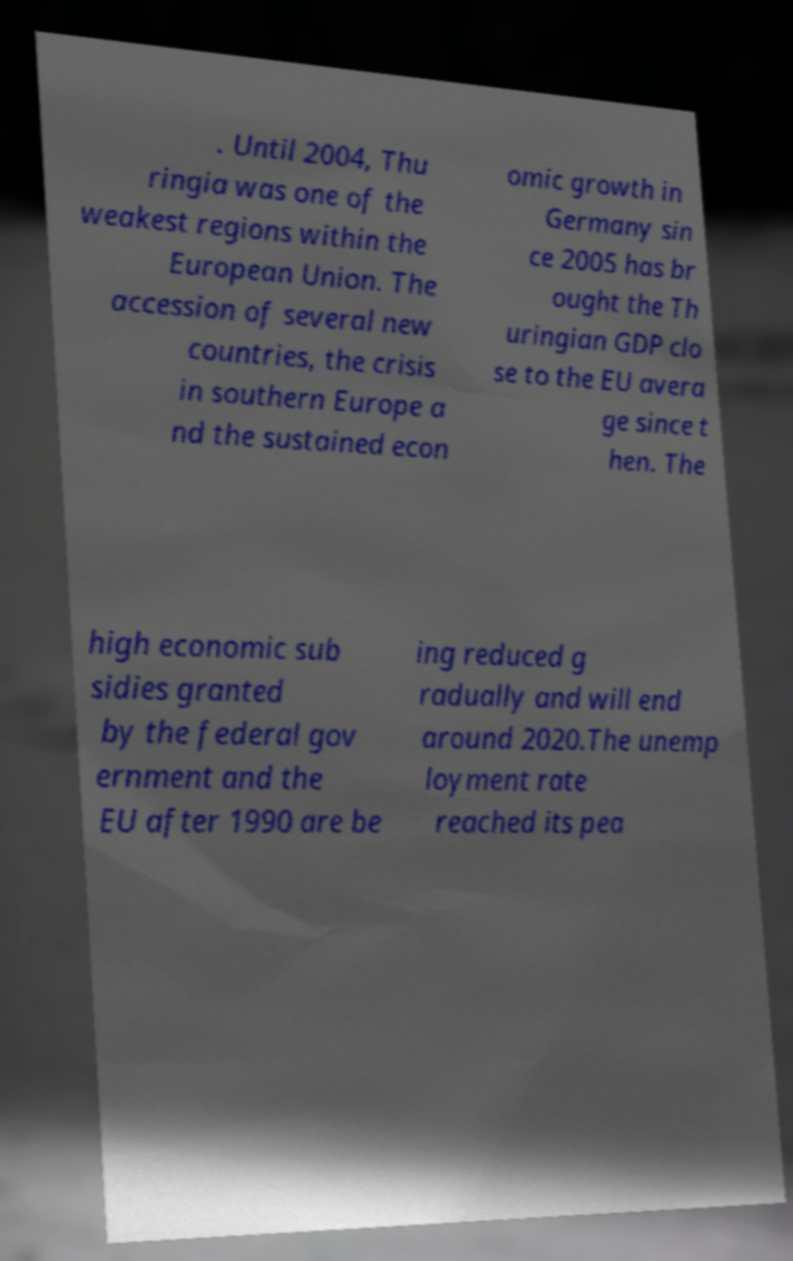There's text embedded in this image that I need extracted. Can you transcribe it verbatim? . Until 2004, Thu ringia was one of the weakest regions within the European Union. The accession of several new countries, the crisis in southern Europe a nd the sustained econ omic growth in Germany sin ce 2005 has br ought the Th uringian GDP clo se to the EU avera ge since t hen. The high economic sub sidies granted by the federal gov ernment and the EU after 1990 are be ing reduced g radually and will end around 2020.The unemp loyment rate reached its pea 